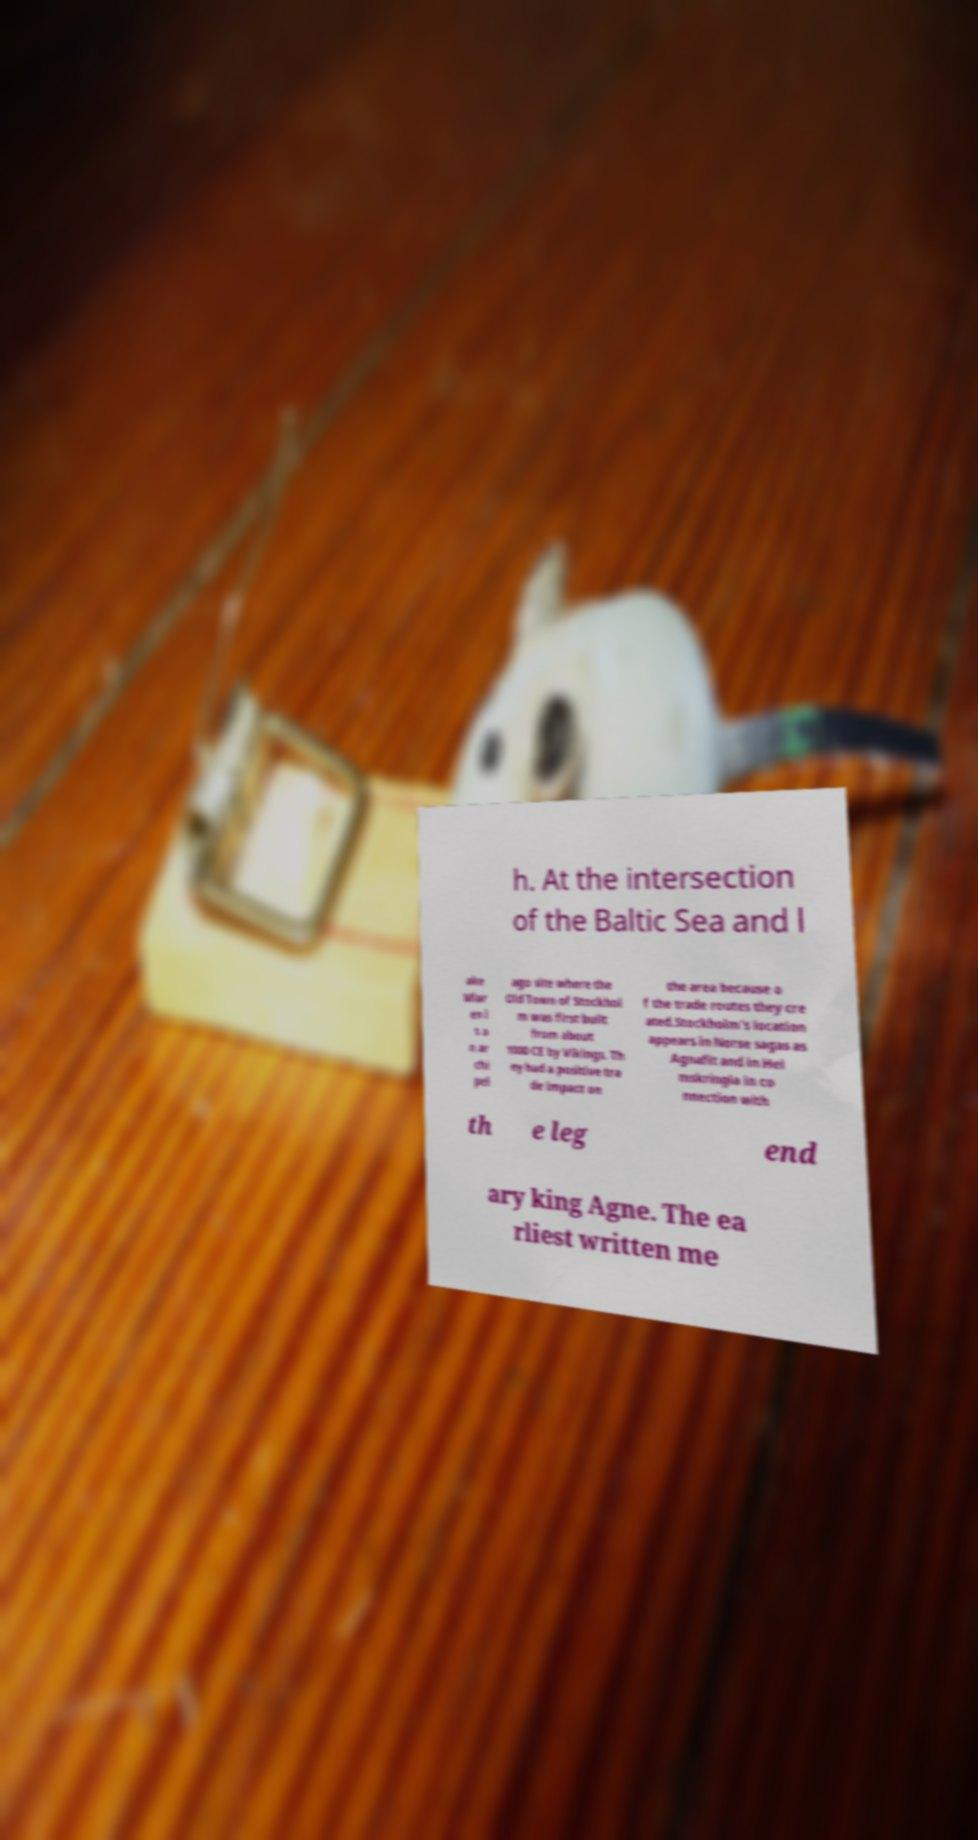What messages or text are displayed in this image? I need them in a readable, typed format. h. At the intersection of the Baltic Sea and l ake Mlar en i s a n ar chi pel ago site where the Old Town of Stockhol m was first built from about 1000 CE by Vikings. Th ey had a positive tra de impact on the area because o f the trade routes they cre ated.Stockholm's location appears in Norse sagas as Agnafit and in Hei mskringla in co nnection with th e leg end ary king Agne. The ea rliest written me 